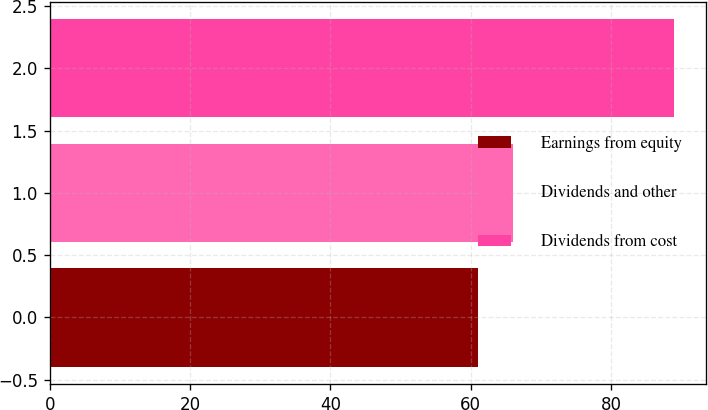Convert chart. <chart><loc_0><loc_0><loc_500><loc_500><bar_chart><fcel>Earnings from equity<fcel>Dividends and other<fcel>Dividends from cost<nl><fcel>61<fcel>66<fcel>89<nl></chart> 